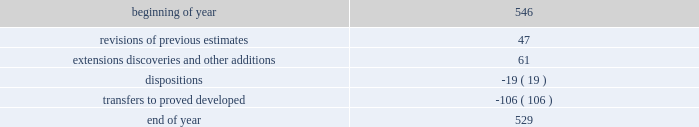Supplementary information on oil and gas producing activities ( unaudited ) 2018 proved reserves decreased by 168 mmboe primarily due to the following : 2022 revisions of previous estimates : increased by 84 mmboe including an increase of 108 mmboe associated with the acceleration of higher economic wells in the u.s .
Resource plays into the 5-year plan and an increase of 15 mmboe associated with wells to sales that were additions to the plan , partially offset by a decrease of 39 mmboe due to technical revisions across the business .
2022 extensions , discoveries , and other additions : increased by 102 mmboe primarily in the u.s .
Resource plays due to an increase of 69 mmboe associated with the expansion of proved areas and an increase of 33 mmboe associated with wells to sales from unproved categories .
2022 production : decreased by 153 mmboe .
2022 sales of reserves in place : decreased by 201 mmboe including 196 mmboe associated with the sale of our subsidiary in libya , 4 mmboe associated with divestitures of certain conventional assets in new mexico and michigan , and 1 mmboe associated with the sale of the sarsang block in kurdistan .
2017 proved reserves decreased by 647 mmboe primarily due to the following : 2022 revisions of previous estimates : increased by 49 mmboe primarily due to the acceleration of higher economic wells in the bakken into the 5-year plan resulting in an increase of 44 mmboe , with the remainder being due to revisions across the business .
2022 extensions , discoveries , and other additions : increased by 116 mmboe primarily due to an increase of 97 mmboe associated with the expansion of proved areas and wells to sales from unproved categories in oklahoma .
2022 purchases of reserves in place : increased by 28 mmboe from acquisitions of assets in the northern delaware basin in new mexico .
2022 production : decreased by 145 mmboe .
2022 sales of reserves in place : decreased by 695 mmboe including 685 mmboe associated with the sale of our canadian business and 10 mmboe associated with divestitures of certain conventional assets in oklahoma and colorado .
See item 8 .
Financial statements and supplementary data - note 5 to the consolidated financial statements for information regarding these dispositions .
2016 proved reserves decreased by 67 mmboe primarily due to the following : 2022 revisions of previous estimates : increased by 63 mmboe primarily due to an increase of 151 mmboe associated with the acceleration of higher economic wells in the u.s .
Resource plays into the 5-year plan and a decrease of 64 mmboe due to u.s .
Technical revisions .
2022 extensions , discoveries , and other additions : increased by 60 mmboe primarily associated with the expansion of proved areas and new wells to sales from unproven categories in oklahoma .
2022 purchases of reserves in place : increased by 34 mmboe from acquisition of stack assets in oklahoma .
2022 production : decreased by 144 mmboe .
2022 sales of reserves in place : decreased by 84 mmboe associated with the divestitures of certain wyoming and gulf of mexico assets .
Changes in proved undeveloped reserves as of december 31 , 2018 , 529 mmboe of proved undeveloped reserves were reported , a decrease of 17 mmboe from december 31 , 2017 .
The table shows changes in proved undeveloped reserves for 2018 : ( mmboe ) .

What percentage of 2018 ending balance of proven undeveloped reserves consisted ofextensions discoveries and other additions? 
Computations: (61 / 529)
Answer: 0.11531. 